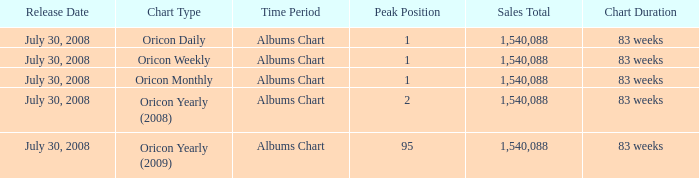Which Chart has a Peak Position of 1? Oricon Daily Albums Chart, Oricon Weekly Albums Chart, Oricon Monthly Albums Chart. 